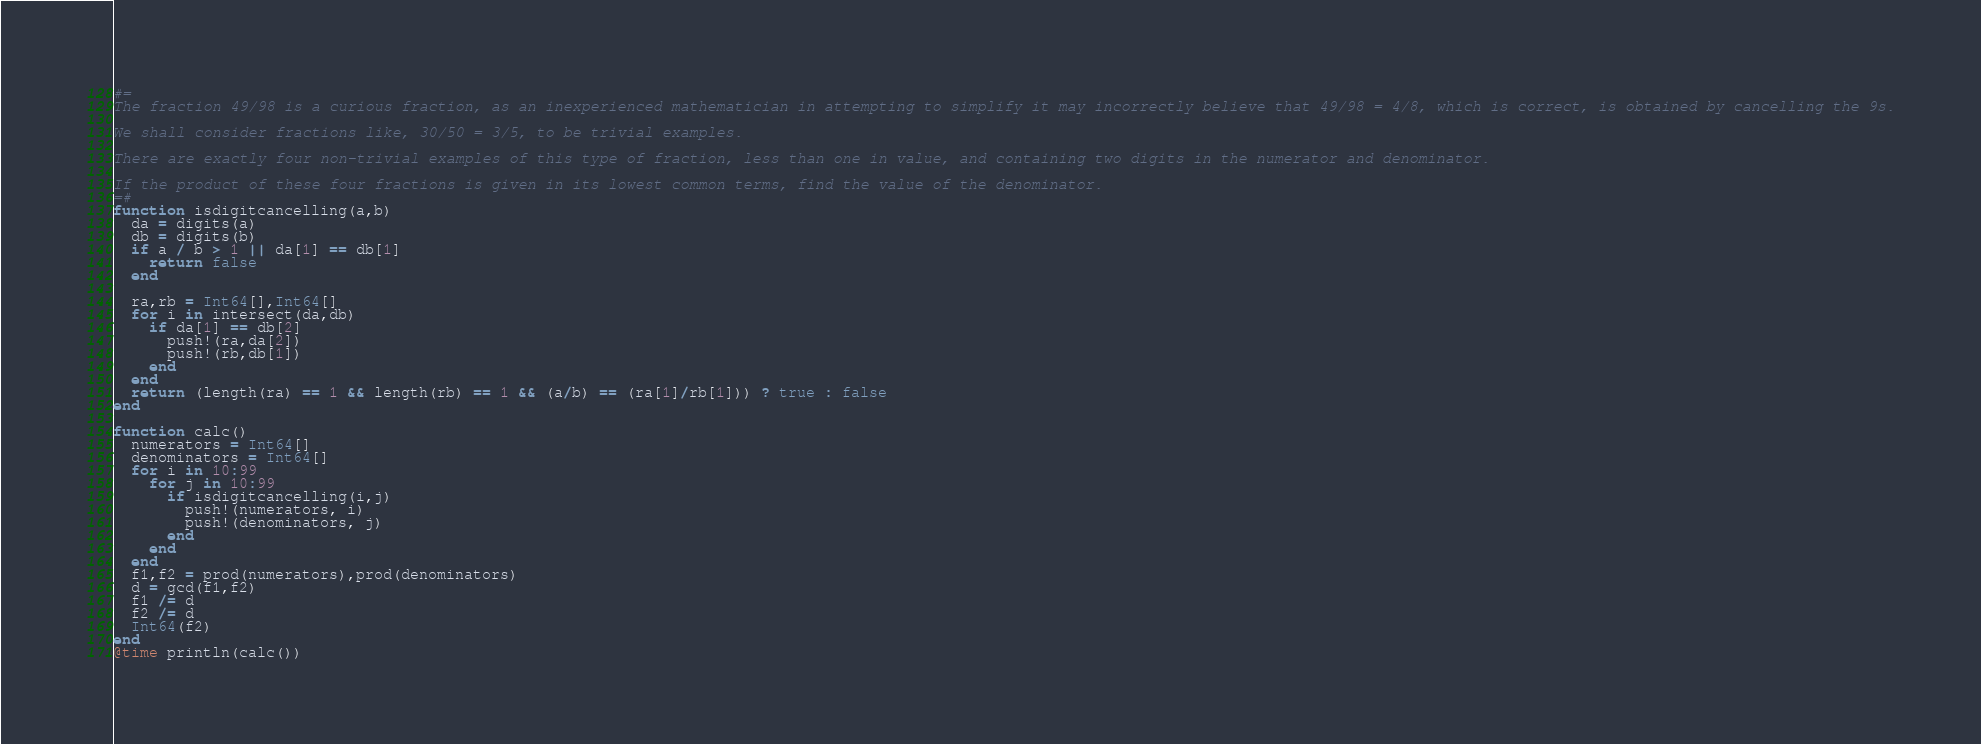Convert code to text. <code><loc_0><loc_0><loc_500><loc_500><_Julia_>#=
The fraction 49/98 is a curious fraction, as an inexperienced mathematician in attempting to simplify it may incorrectly believe that 49/98 = 4/8, which is correct, is obtained by cancelling the 9s.

We shall consider fractions like, 30/50 = 3/5, to be trivial examples.

There are exactly four non-trivial examples of this type of fraction, less than one in value, and containing two digits in the numerator and denominator.

If the product of these four fractions is given in its lowest common terms, find the value of the denominator.
=#
function isdigitcancelling(a,b)
  da = digits(a)
  db = digits(b)
  if a / b > 1 || da[1] == db[1]
    return false
  end

  ra,rb = Int64[],Int64[]
  for i in intersect(da,db)
    if da[1] == db[2]
      push!(ra,da[2])
      push!(rb,db[1])
    end
  end
  return (length(ra) == 1 && length(rb) == 1 && (a/b) == (ra[1]/rb[1])) ? true : false
end

function calc()
  numerators = Int64[]
  denominators = Int64[]
  for i in 10:99
    for j in 10:99
      if isdigitcancelling(i,j)
        push!(numerators, i)
        push!(denominators, j)
      end
    end
  end
  f1,f2 = prod(numerators),prod(denominators)
  d = gcd(f1,f2)
  f1 /= d
  f2 /= d
  Int64(f2)
end
@time println(calc())
</code> 